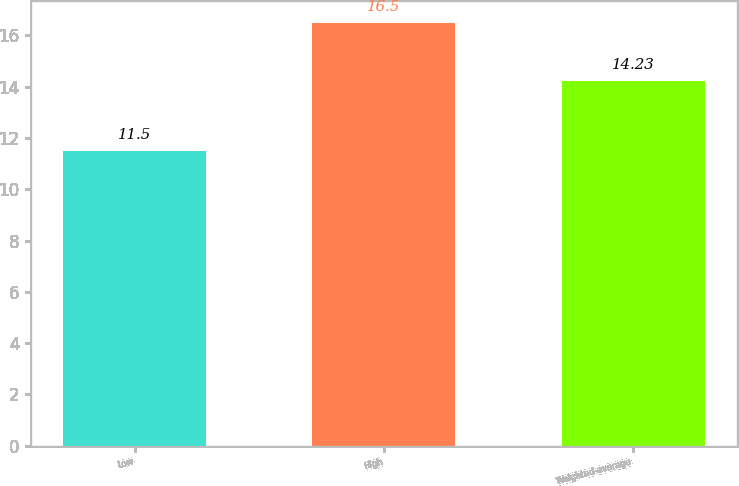<chart> <loc_0><loc_0><loc_500><loc_500><bar_chart><fcel>Low<fcel>High<fcel>Weighted-average<nl><fcel>11.5<fcel>16.5<fcel>14.23<nl></chart> 